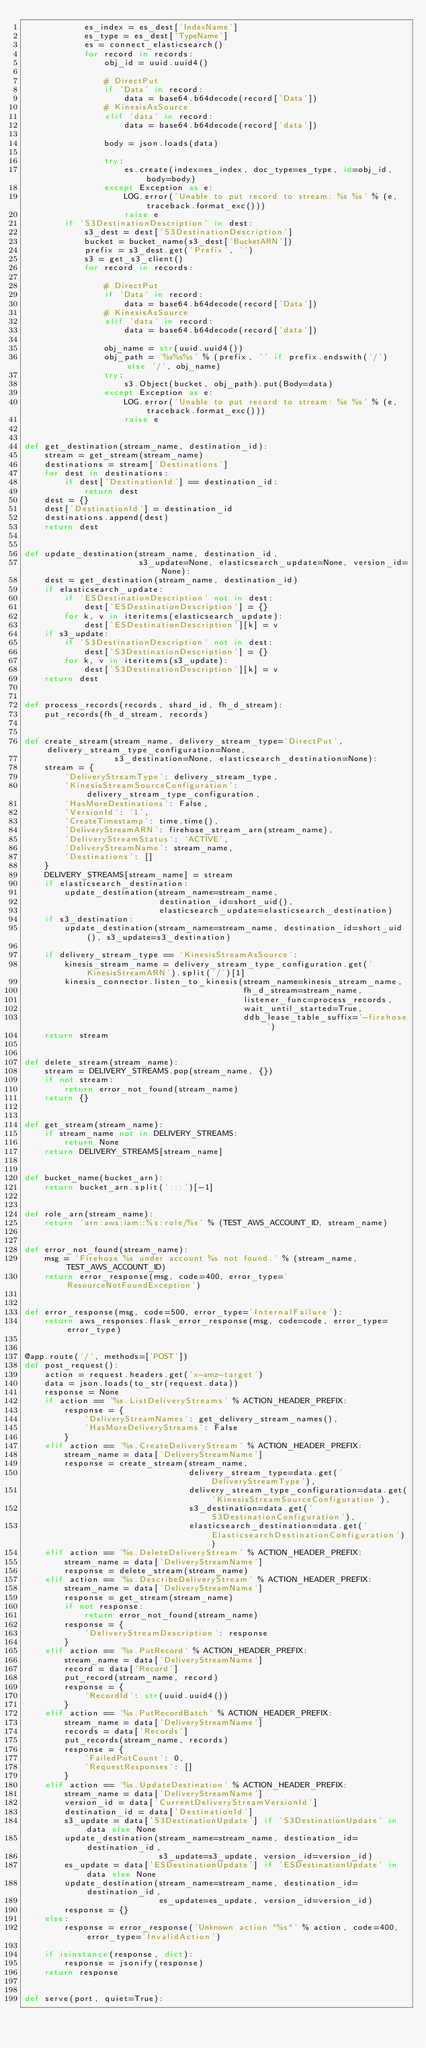Convert code to text. <code><loc_0><loc_0><loc_500><loc_500><_Python_>            es_index = es_dest['IndexName']
            es_type = es_dest['TypeName']
            es = connect_elasticsearch()
            for record in records:
                obj_id = uuid.uuid4()

                # DirectPut
                if 'Data' in record:
                    data = base64.b64decode(record['Data'])
                # KinesisAsSource
                elif 'data' in record:
                    data = base64.b64decode(record['data'])

                body = json.loads(data)

                try:
                    es.create(index=es_index, doc_type=es_type, id=obj_id, body=body)
                except Exception as e:
                    LOG.error('Unable to put record to stream: %s %s' % (e, traceback.format_exc()))
                    raise e
        if 'S3DestinationDescription' in dest:
            s3_dest = dest['S3DestinationDescription']
            bucket = bucket_name(s3_dest['BucketARN'])
            prefix = s3_dest.get('Prefix', '')
            s3 = get_s3_client()
            for record in records:

                # DirectPut
                if 'Data' in record:
                    data = base64.b64decode(record['Data'])
                # KinesisAsSource
                elif 'data' in record:
                    data = base64.b64decode(record['data'])

                obj_name = str(uuid.uuid4())
                obj_path = '%s%s%s' % (prefix, '' if prefix.endswith('/') else '/', obj_name)
                try:
                    s3.Object(bucket, obj_path).put(Body=data)
                except Exception as e:
                    LOG.error('Unable to put record to stream: %s %s' % (e, traceback.format_exc()))
                    raise e


def get_destination(stream_name, destination_id):
    stream = get_stream(stream_name)
    destinations = stream['Destinations']
    for dest in destinations:
        if dest['DestinationId'] == destination_id:
            return dest
    dest = {}
    dest['DestinationId'] = destination_id
    destinations.append(dest)
    return dest


def update_destination(stream_name, destination_id,
                       s3_update=None, elasticsearch_update=None, version_id=None):
    dest = get_destination(stream_name, destination_id)
    if elasticsearch_update:
        if 'ESDestinationDescription' not in dest:
            dest['ESDestinationDescription'] = {}
        for k, v in iteritems(elasticsearch_update):
            dest['ESDestinationDescription'][k] = v
    if s3_update:
        if 'S3DestinationDescription' not in dest:
            dest['S3DestinationDescription'] = {}
        for k, v in iteritems(s3_update):
            dest['S3DestinationDescription'][k] = v
    return dest


def process_records(records, shard_id, fh_d_stream):
    put_records(fh_d_stream, records)


def create_stream(stream_name, delivery_stream_type='DirectPut', delivery_stream_type_configuration=None,
                  s3_destination=None, elasticsearch_destination=None):
    stream = {
        'DeliveryStreamType': delivery_stream_type,
        'KinesisStreamSourceConfiguration': delivery_stream_type_configuration,
        'HasMoreDestinations': False,
        'VersionId': '1',
        'CreateTimestamp': time.time(),
        'DeliveryStreamARN': firehose_stream_arn(stream_name),
        'DeliveryStreamStatus': 'ACTIVE',
        'DeliveryStreamName': stream_name,
        'Destinations': []
    }
    DELIVERY_STREAMS[stream_name] = stream
    if elasticsearch_destination:
        update_destination(stream_name=stream_name,
                           destination_id=short_uid(),
                           elasticsearch_update=elasticsearch_destination)
    if s3_destination:
        update_destination(stream_name=stream_name, destination_id=short_uid(), s3_update=s3_destination)

    if delivery_stream_type == 'KinesisStreamAsSource':
        kinesis_stream_name = delivery_stream_type_configuration.get('KinesisStreamARN').split('/')[1]
        kinesis_connector.listen_to_kinesis(stream_name=kinesis_stream_name,
                                            fh_d_stream=stream_name,
                                            listener_func=process_records,
                                            wait_until_started=True,
                                            ddb_lease_table_suffix='-firehose')
    return stream


def delete_stream(stream_name):
    stream = DELIVERY_STREAMS.pop(stream_name, {})
    if not stream:
        return error_not_found(stream_name)
    return {}


def get_stream(stream_name):
    if stream_name not in DELIVERY_STREAMS:
        return None
    return DELIVERY_STREAMS[stream_name]


def bucket_name(bucket_arn):
    return bucket_arn.split(':::')[-1]


def role_arn(stream_name):
    return 'arn:aws:iam::%s:role/%s' % (TEST_AWS_ACCOUNT_ID, stream_name)


def error_not_found(stream_name):
    msg = 'Firehose %s under account %s not found.' % (stream_name, TEST_AWS_ACCOUNT_ID)
    return error_response(msg, code=400, error_type='ResourceNotFoundException')


def error_response(msg, code=500, error_type='InternalFailure'):
    return aws_responses.flask_error_response(msg, code=code, error_type=error_type)


@app.route('/', methods=['POST'])
def post_request():
    action = request.headers.get('x-amz-target')
    data = json.loads(to_str(request.data))
    response = None
    if action == '%s.ListDeliveryStreams' % ACTION_HEADER_PREFIX:
        response = {
            'DeliveryStreamNames': get_delivery_stream_names(),
            'HasMoreDeliveryStreams': False
        }
    elif action == '%s.CreateDeliveryStream' % ACTION_HEADER_PREFIX:
        stream_name = data['DeliveryStreamName']
        response = create_stream(stream_name,
                                 delivery_stream_type=data.get('DeliveryStreamType'),
                                 delivery_stream_type_configuration=data.get('KinesisStreamSourceConfiguration'),
                                 s3_destination=data.get('S3DestinationConfiguration'),
                                 elasticsearch_destination=data.get('ElasticsearchDestinationConfiguration'))
    elif action == '%s.DeleteDeliveryStream' % ACTION_HEADER_PREFIX:
        stream_name = data['DeliveryStreamName']
        response = delete_stream(stream_name)
    elif action == '%s.DescribeDeliveryStream' % ACTION_HEADER_PREFIX:
        stream_name = data['DeliveryStreamName']
        response = get_stream(stream_name)
        if not response:
            return error_not_found(stream_name)
        response = {
            'DeliveryStreamDescription': response
        }
    elif action == '%s.PutRecord' % ACTION_HEADER_PREFIX:
        stream_name = data['DeliveryStreamName']
        record = data['Record']
        put_record(stream_name, record)
        response = {
            'RecordId': str(uuid.uuid4())
        }
    elif action == '%s.PutRecordBatch' % ACTION_HEADER_PREFIX:
        stream_name = data['DeliveryStreamName']
        records = data['Records']
        put_records(stream_name, records)
        response = {
            'FailedPutCount': 0,
            'RequestResponses': []
        }
    elif action == '%s.UpdateDestination' % ACTION_HEADER_PREFIX:
        stream_name = data['DeliveryStreamName']
        version_id = data['CurrentDeliveryStreamVersionId']
        destination_id = data['DestinationId']
        s3_update = data['S3DestinationUpdate'] if 'S3DestinationUpdate' in data else None
        update_destination(stream_name=stream_name, destination_id=destination_id,
                           s3_update=s3_update, version_id=version_id)
        es_update = data['ESDestinationUpdate'] if 'ESDestinationUpdate' in data else None
        update_destination(stream_name=stream_name, destination_id=destination_id,
                           es_update=es_update, version_id=version_id)
        response = {}
    else:
        response = error_response('Unknown action "%s"' % action, code=400, error_type='InvalidAction')

    if isinstance(response, dict):
        response = jsonify(response)
    return response


def serve(port, quiet=True):</code> 